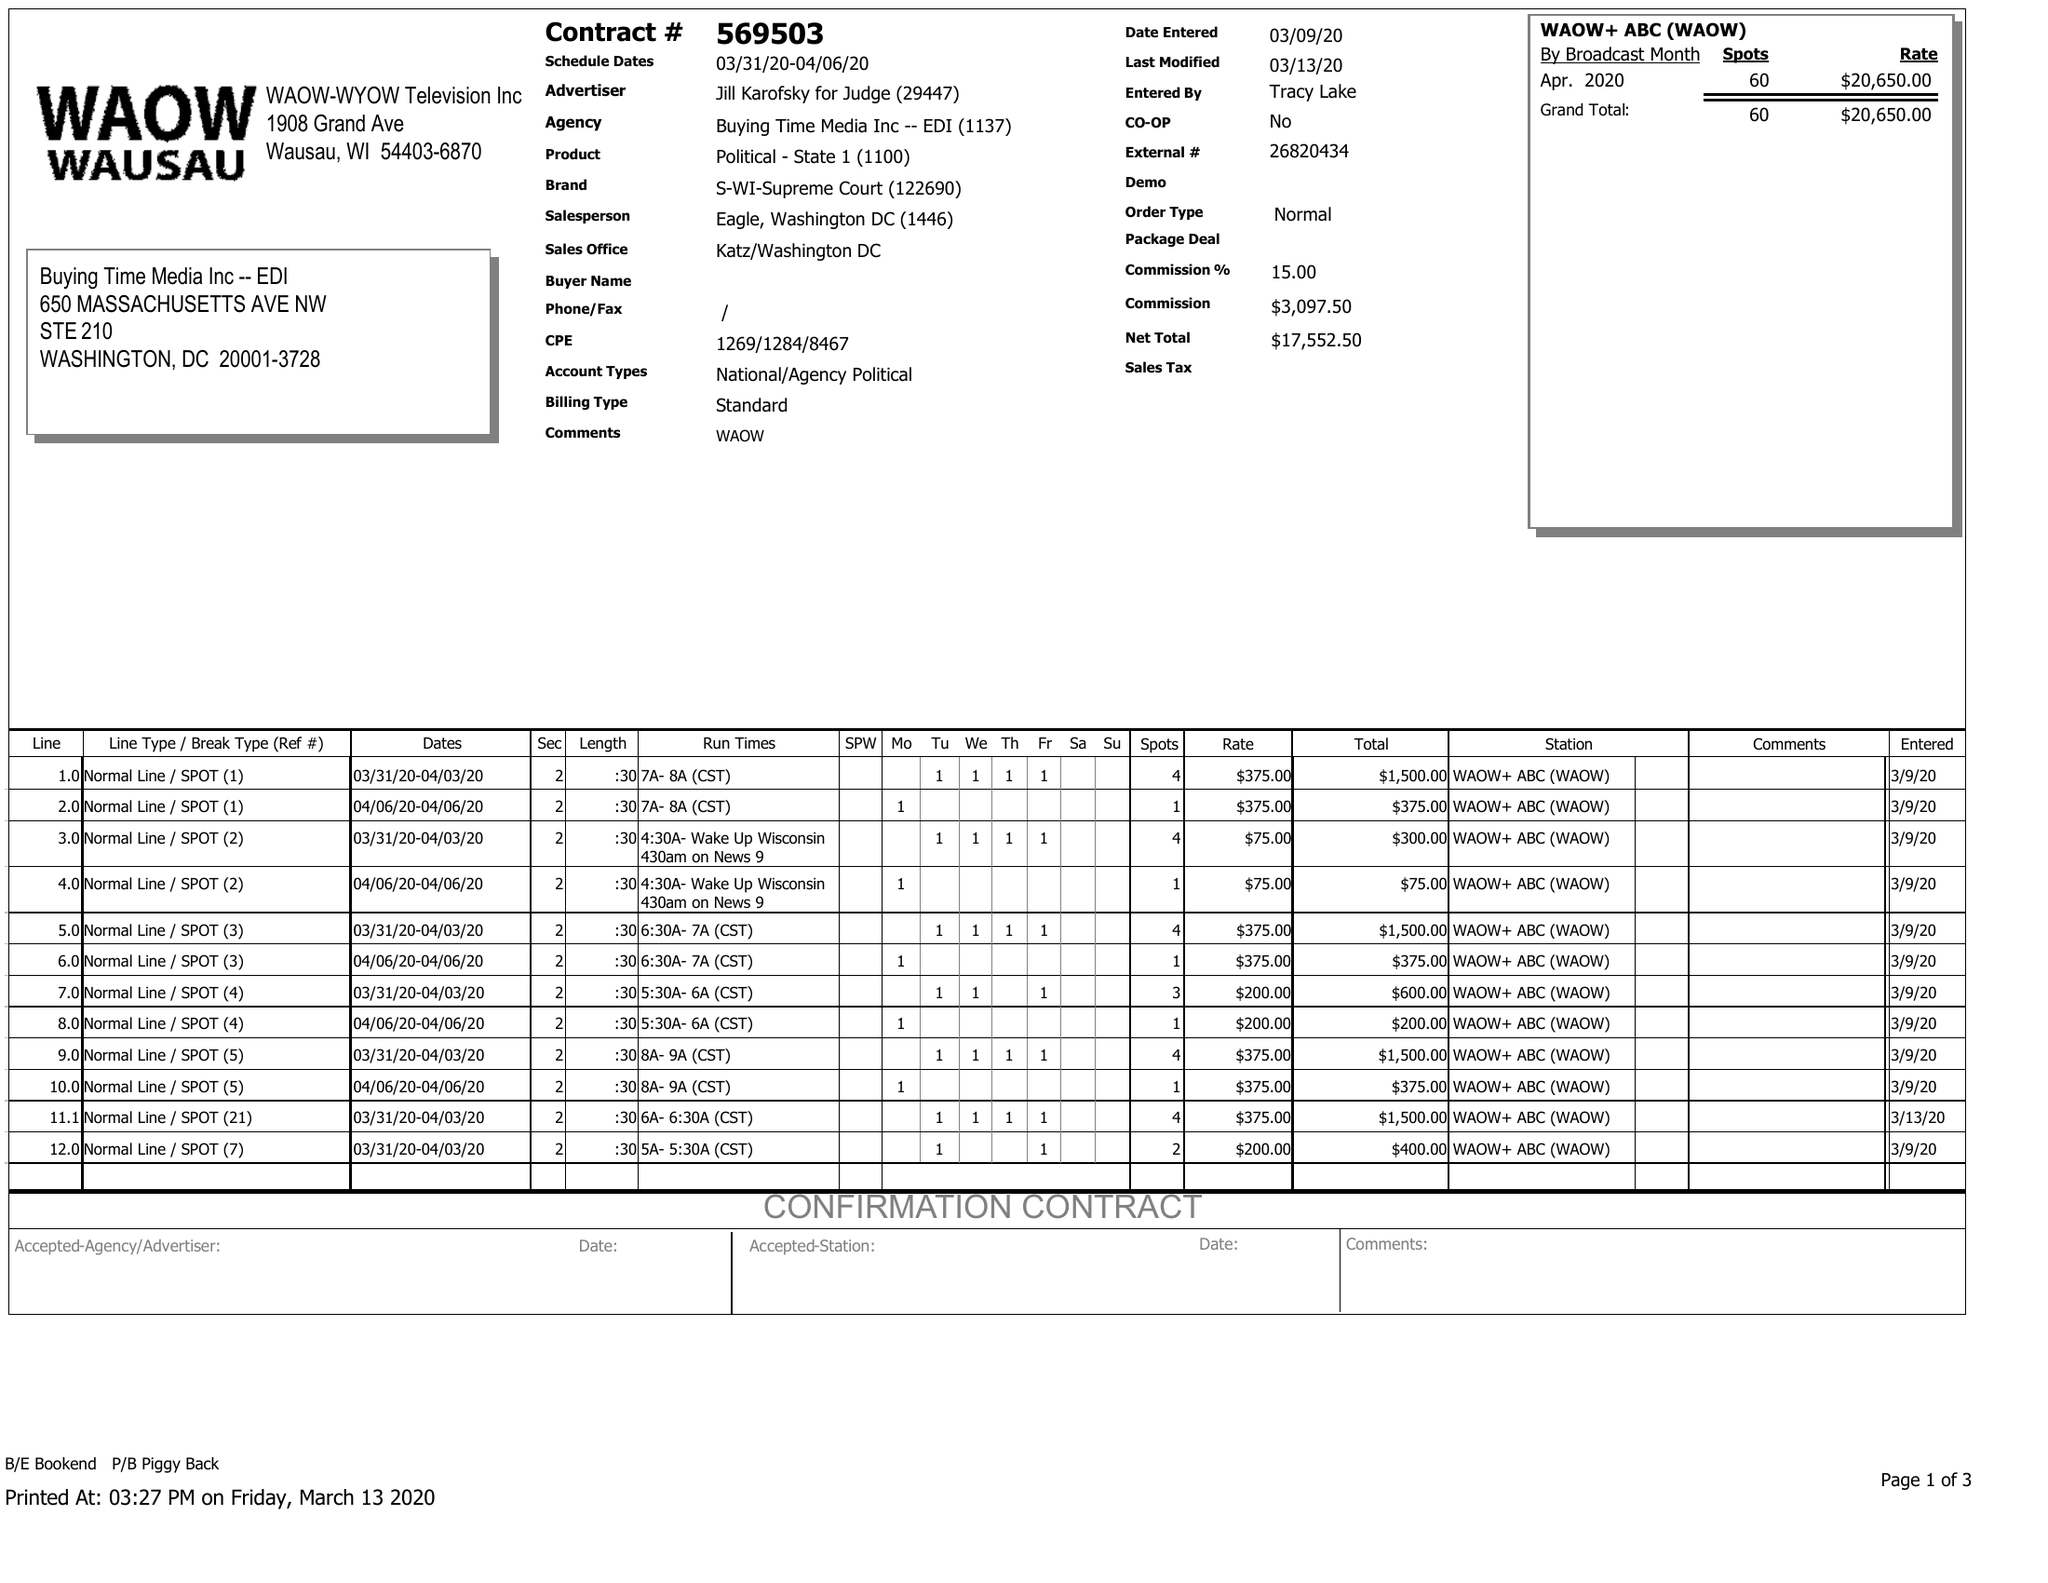What is the value for the gross_amount?
Answer the question using a single word or phrase. 20650.00 